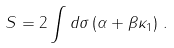<formula> <loc_0><loc_0><loc_500><loc_500>S = 2 \int d \sigma \left ( \alpha + \beta \kappa _ { 1 } \right ) \, .</formula> 